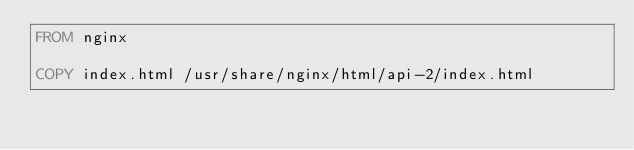<code> <loc_0><loc_0><loc_500><loc_500><_Dockerfile_>FROM nginx

COPY index.html /usr/share/nginx/html/api-2/index.html
</code> 